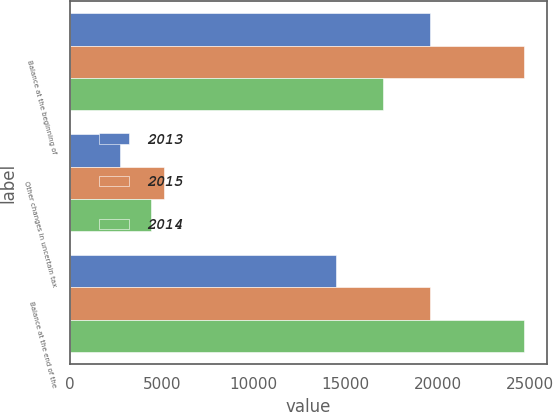<chart> <loc_0><loc_0><loc_500><loc_500><stacked_bar_chart><ecel><fcel>Balance at the beginning of<fcel>Other changes in uncertain tax<fcel>Balance at the end of the<nl><fcel>2013<fcel>19596<fcel>2741<fcel>14450<nl><fcel>2015<fcel>24716<fcel>5120<fcel>19596<nl><fcel>2014<fcel>17023<fcel>4395<fcel>24716<nl></chart> 